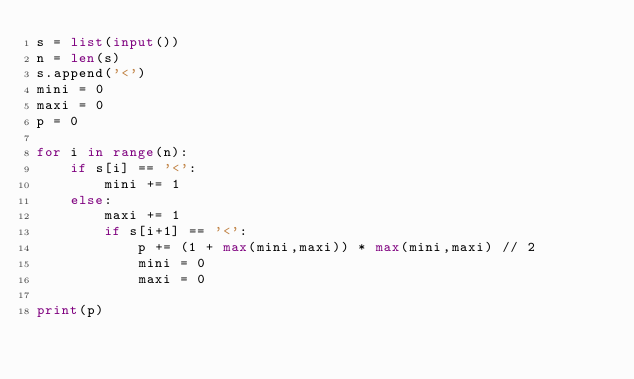Convert code to text. <code><loc_0><loc_0><loc_500><loc_500><_Python_>s = list(input())
n = len(s)
s.append('<')
mini = 0
maxi = 0
p = 0

for i in range(n):
    if s[i] == '<':
        mini += 1
    else:
        maxi += 1
        if s[i+1] == '<':
            p += (1 + max(mini,maxi)) * max(mini,maxi) // 2
            mini = 0
            maxi = 0

print(p)</code> 